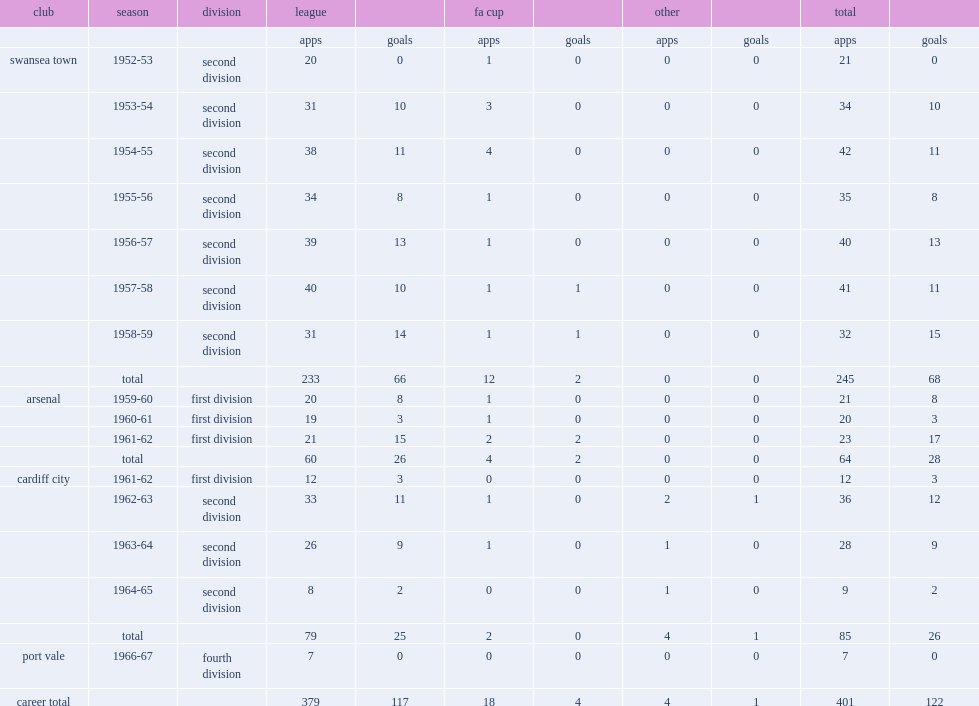Help me parse the entirety of this table. {'header': ['club', 'season', 'division', 'league', '', 'fa cup', '', 'other', '', 'total', ''], 'rows': [['', '', '', 'apps', 'goals', 'apps', 'goals', 'apps', 'goals', 'apps', 'goals'], ['swansea town', '1952-53', 'second division', '20', '0', '1', '0', '0', '0', '21', '0'], ['', '1953-54', 'second division', '31', '10', '3', '0', '0', '0', '34', '10'], ['', '1954-55', 'second division', '38', '11', '4', '0', '0', '0', '42', '11'], ['', '1955-56', 'second division', '34', '8', '1', '0', '0', '0', '35', '8'], ['', '1956-57', 'second division', '39', '13', '1', '0', '0', '0', '40', '13'], ['', '1957-58', 'second division', '40', '10', '1', '1', '0', '0', '41', '11'], ['', '1958-59', 'second division', '31', '14', '1', '1', '0', '0', '32', '15'], ['', 'total', '', '233', '66', '12', '2', '0', '0', '245', '68'], ['arsenal', '1959-60', 'first division', '20', '8', '1', '0', '0', '0', '21', '8'], ['', '1960-61', 'first division', '19', '3', '1', '0', '0', '0', '20', '3'], ['', '1961-62', 'first division', '21', '15', '2', '2', '0', '0', '23', '17'], ['', 'total', '', '60', '26', '4', '2', '0', '0', '64', '28'], ['cardiff city', '1961-62', 'first division', '12', '3', '0', '0', '0', '0', '12', '3'], ['', '1962-63', 'second division', '33', '11', '1', '0', '2', '1', '36', '12'], ['', '1963-64', 'second division', '26', '9', '1', '0', '1', '0', '28', '9'], ['', '1964-65', 'second division', '8', '2', '0', '0', '1', '0', '9', '2'], ['', 'total', '', '79', '25', '2', '0', '4', '1', '85', '26'], ['port vale', '1966-67', 'fourth division', '7', '0', '0', '0', '0', '0', '7', '0'], ['career total', '', '', '379', '117', '18', '4', '4', '1', '401', '122']]} Which division was mel charles with port vale in the 1966-67 season? Fourth division. 